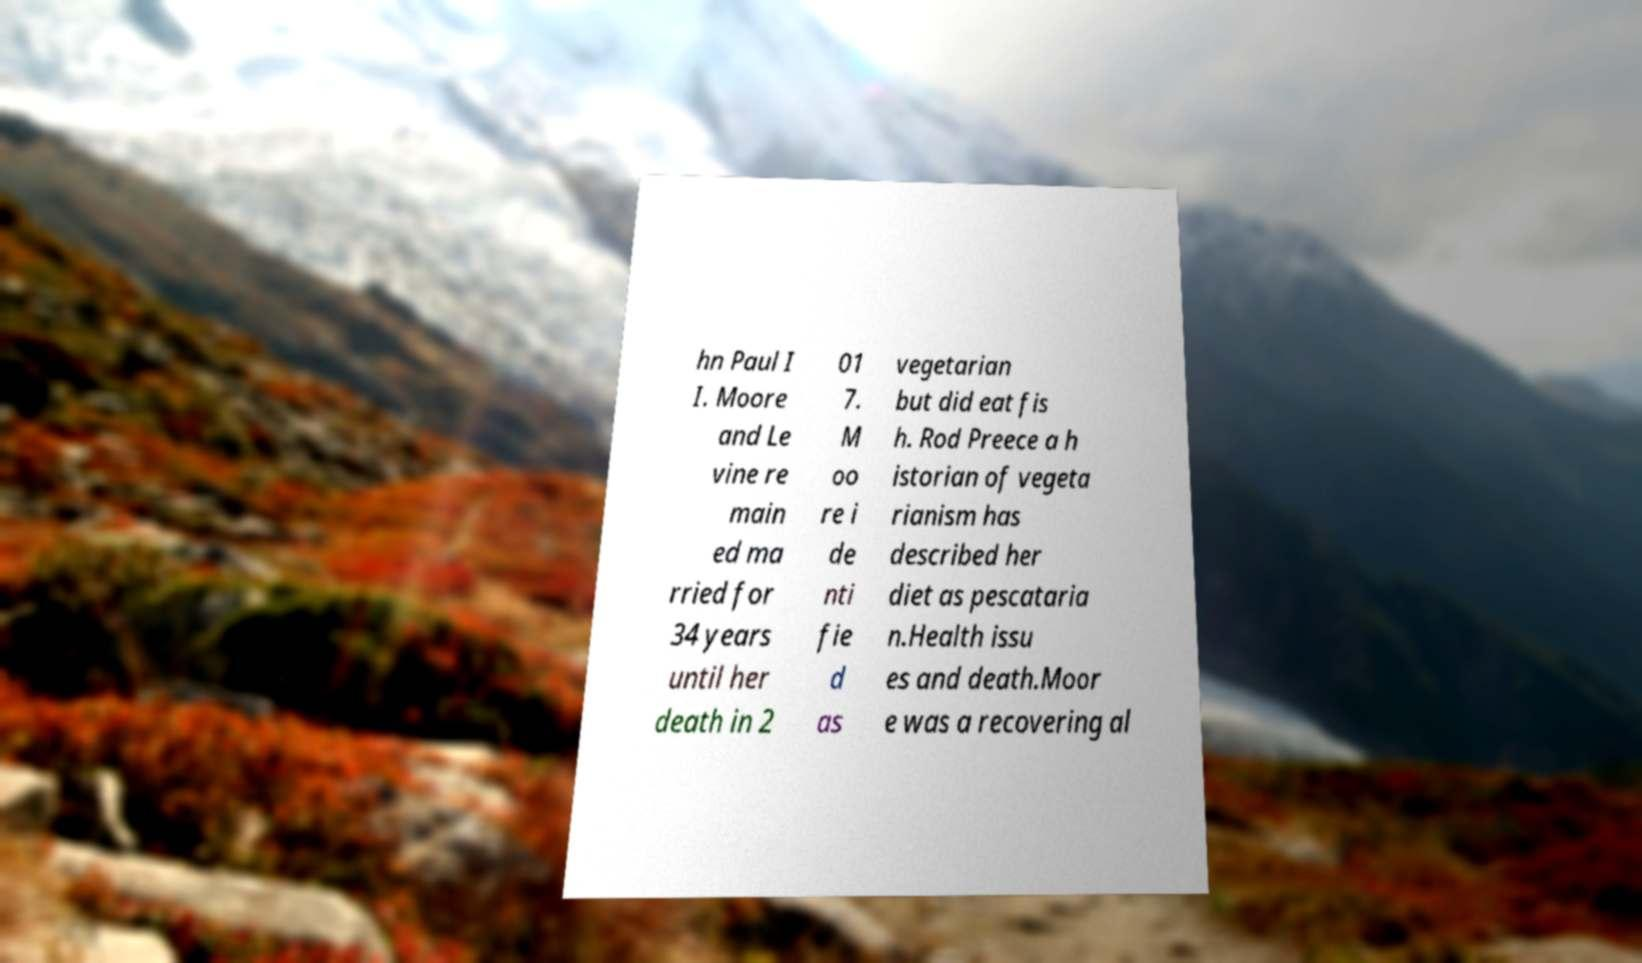What messages or text are displayed in this image? I need them in a readable, typed format. hn Paul I I. Moore and Le vine re main ed ma rried for 34 years until her death in 2 01 7. M oo re i de nti fie d as vegetarian but did eat fis h. Rod Preece a h istorian of vegeta rianism has described her diet as pescataria n.Health issu es and death.Moor e was a recovering al 